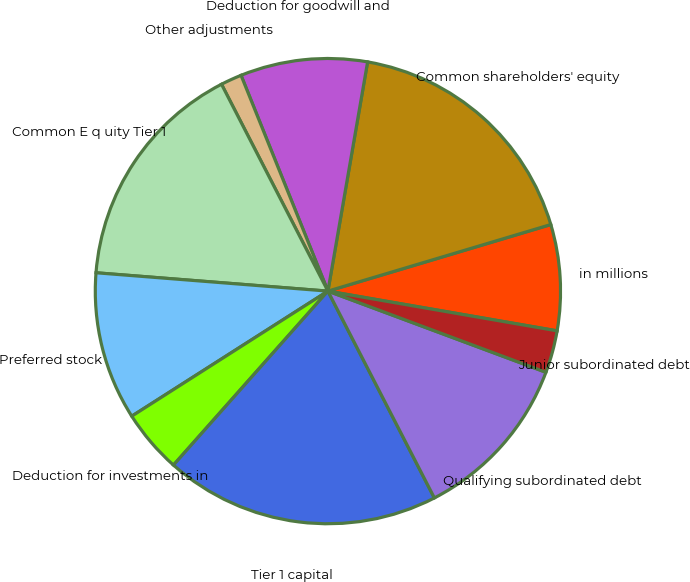Convert chart to OTSL. <chart><loc_0><loc_0><loc_500><loc_500><pie_chart><fcel>in millions<fcel>Common shareholders' equity<fcel>Deduction for goodwill and<fcel>Other adjustments<fcel>Common E q uity Tier 1<fcel>Preferred stock<fcel>Deduction for investments in<fcel>Tier 1 capital<fcel>Qualifying subordinated debt<fcel>Junior subordinated debt<nl><fcel>7.35%<fcel>17.65%<fcel>8.82%<fcel>1.47%<fcel>16.18%<fcel>10.29%<fcel>4.41%<fcel>19.12%<fcel>11.76%<fcel>2.94%<nl></chart> 